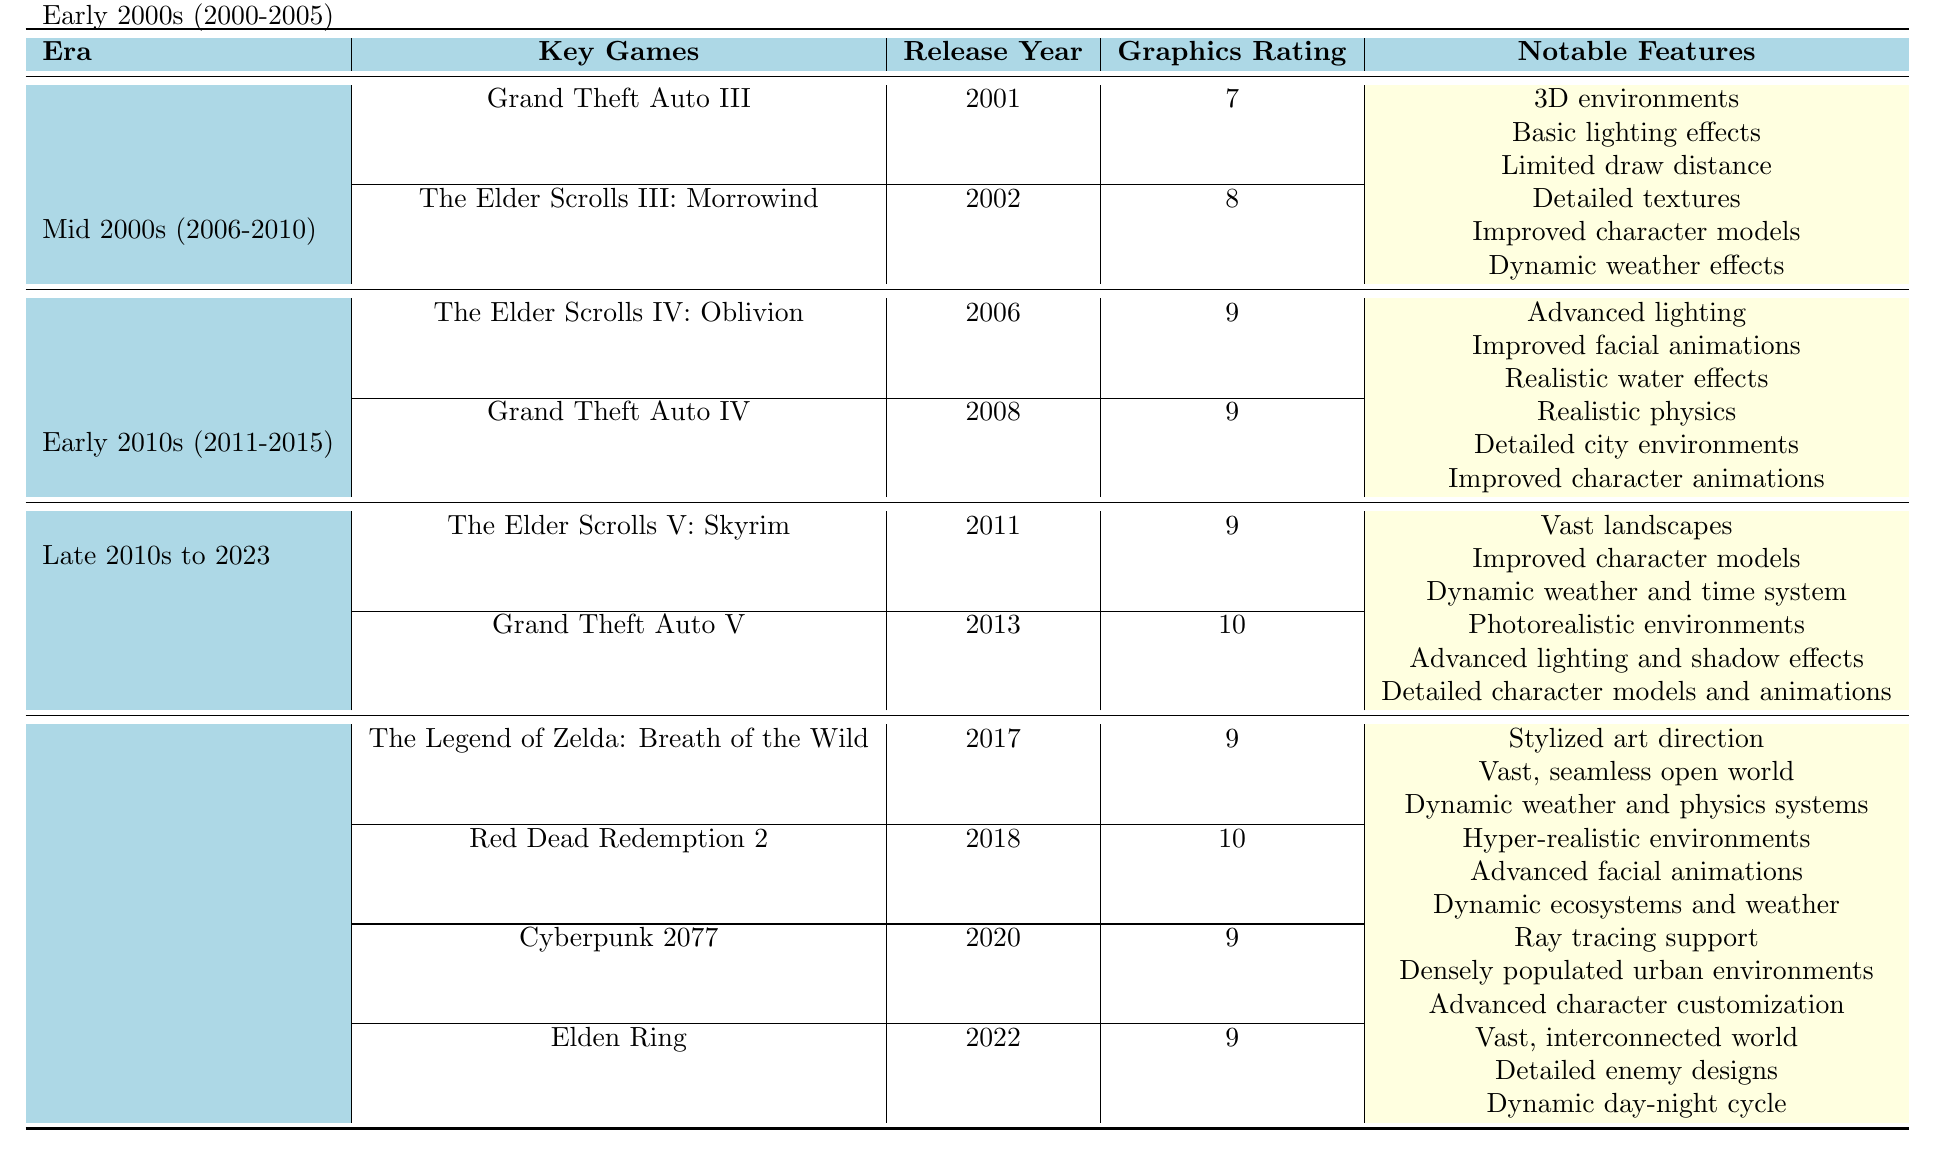What is the average graphics rating for the Early 2000s era? The average graphics rating for the Early 2000s era is provided in the table. It is listed as 7.5.
Answer: 7.5 Which game had the highest graphics rating in the Early 2010s? Based on the table, the game with the highest graphics rating in the Early 2010s is Grand Theft Auto V, which has a rating of 10.
Answer: Grand Theft Auto V Are there any games released in the Early 2000s with a graphics rating of 8 or higher? The Elder Scrolls III: Morrowind was released in the Early 2000s and has a graphics rating of 8, which confirms that there is at least one game with a rating of 8 or higher.
Answer: Yes How much higher is the average graphics rating in the Mid 2000s compared to the Early 2000s? The average graphics rating in the Mid 2000s is 9, and in the Early 2000s, it is 7.5. The difference is calculated as 9 - 7.5 = 1.5.
Answer: 1.5 Which era had the most key games listed, and how many were there? The Late 2010s to 2023 era has 4 key games listed: The Legend of Zelda: Breath of the Wild, Red Dead Redemption 2, Cyberpunk 2077, and Elden Ring.
Answer: Late 2010s to 2023, 4 games What notable feature is shared between Grand Theft Auto V and Red Dead Redemption 2? Both games have detailed character models, as noted under their respective key features in the table.
Answer: Detailed character models What is the trend in graphics ratings from 2000 to 2023? By observing the average ratings, we see an increase from 7.5 in the Early 2000s to 9.25 in the Late 2010s to 2023, indicating a significant improvement in graphics quality.
Answer: Significant improvement Which game features advanced lighting and realistic water effects? The Elder Scrolls IV: Oblivion features advanced lighting and realistic water effects as notable features.
Answer: The Elder Scrolls IV: Oblivion How do the graphics ratings of The Elder Scrolls V: Skyrim and Cyberpunk 2077 compare? The Elder Scrolls V: Skyrim has a graphics rating of 9, while Cyberpunk 2077 has a rating of 9. This means the ratings are the same.
Answer: They are the same List the notable features of the game that has the lowest graphics rating in the table. Grand Theft Auto III has a graphics rating of 7, with notable features including 3D environments, basic lighting effects, and limited draw distance.
Answer: 3D environments, basic lighting effects, limited draw distance What era had the first game to receive a graphics rating of 10, and what was the game? The Early 2010s era had the first game to receive a graphics rating of 10, which was Grand Theft Auto V.
Answer: Early 2010s, Grand Theft Auto V 